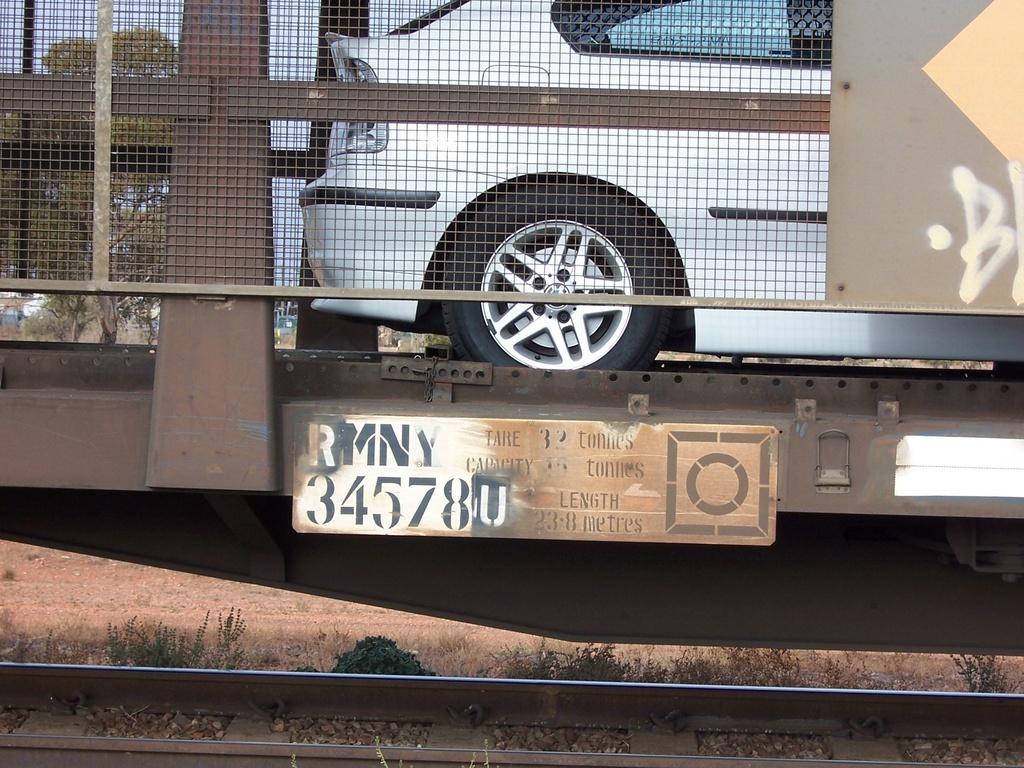Can you describe this image briefly? In this image there is the sky towards the top of the image, there are trees, there is a train towards the top of the image, there is a car towards the top of the image, there are boards, there is text and number on the boards, there is ground, there are plants, there is a railway track towards the bottom of the image. 